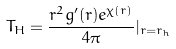<formula> <loc_0><loc_0><loc_500><loc_500>T _ { H } = \frac { r ^ { 2 } g ^ { \prime } ( r ) e ^ { \chi ( r ) } } { 4 \pi } | _ { r = r _ { h } }</formula> 